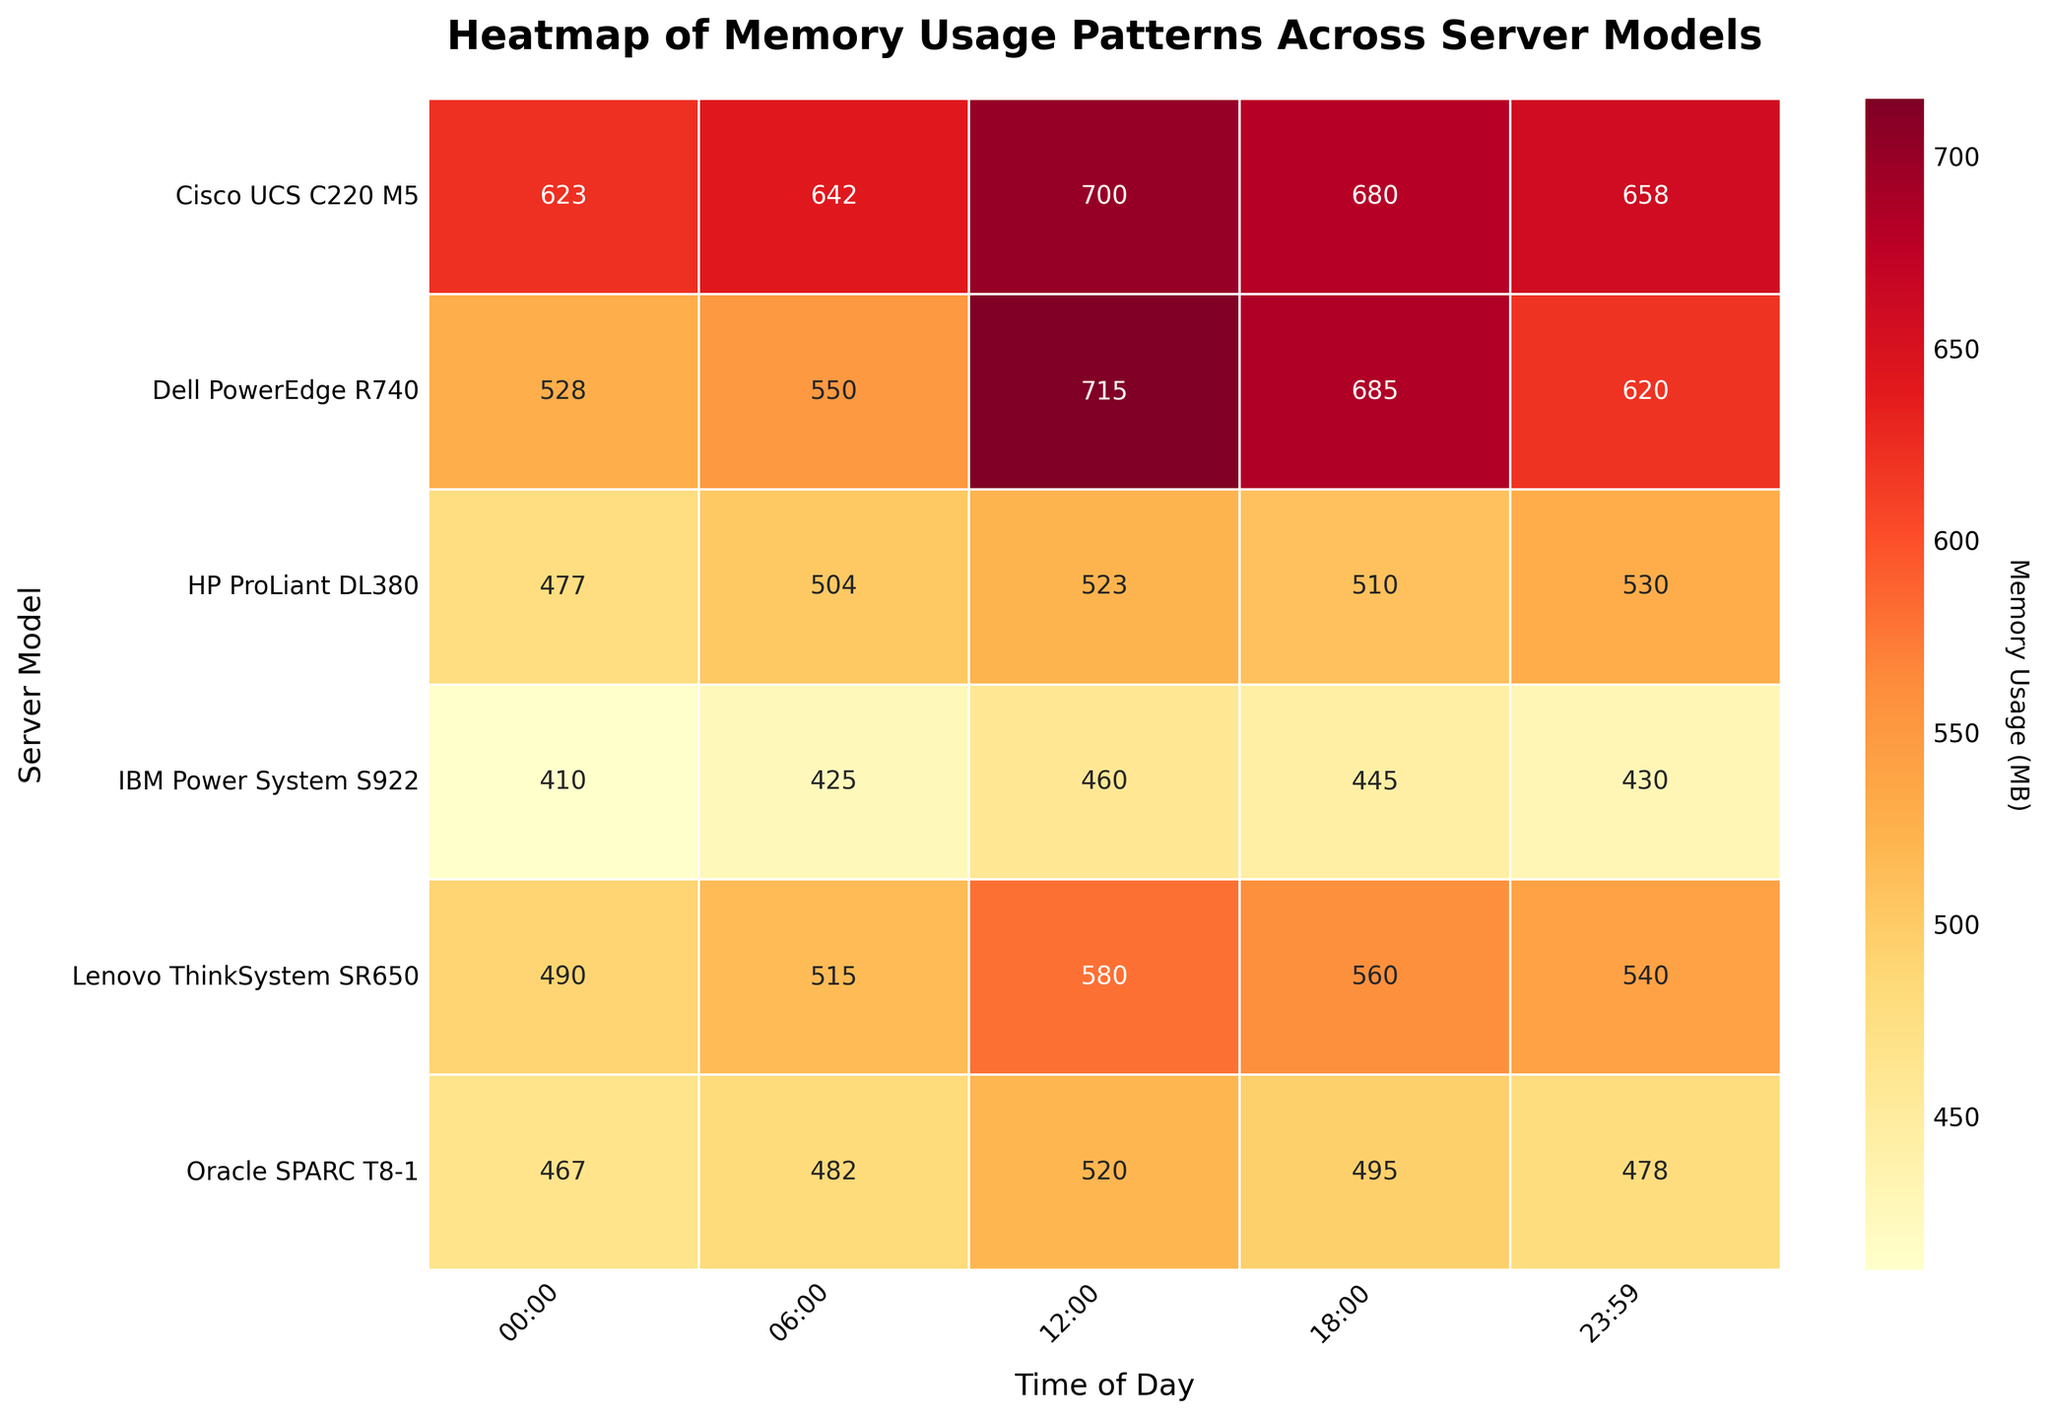What's the title of the heatmap? The title is usually found at the top of the figure, serving as a description of what the heatmap represents.
Answer: Heatmap of Memory Usage Patterns Across Server Models Which server model has the highest memory usage at 12:00? Identify the Time of Day column labeled 12:00, then find the maximum value in that column and note the corresponding server model.
Answer: Dell PowerEdge R740 What is the average memory usage for the Dell PowerEdge R740 across all times of day? Sum the memory usage values for Dell PowerEdge R740 across all times of day and divide by the number of observations (5). Values: 528, 550, 715, 685, 620. Calculation: (528 + 550 + 715 + 685 + 620) / 5 = 3198 / 5 = 639.6
Answer: 639.6 MB Which server model and operating system combination has the lowest memory usage overall? Identify the lowest value in the heatmap and note the corresponding server model and operating system. The lowest value is 410 MB for IBM Power System S922 running AIX 7.2 at 00:00.
Answer: IBM Power System S922, AIX 7.2 How does the memory usage of Cisco UCS C220 M5 at 06:00 compare to 12:00? Locate the memory usage values for Cisco UCS C220 M5 at 06:00 and 12:00 and compare them. At 06:00, it is 642 MB, and at 12:00, it is 700 MB. 700 MB - 642 MB = 58 MB.
Answer: 58 MB more at 12:00 What is the memory usage range for Lenovo ThinkSystem SR650? Find the minimum and maximum memory usage values for Lenovo ThinkSystem SR650 and subtract the minimum from the maximum to get the range. Values: 490 to 580. Calculation: 580 - 490 = 90.
Answer: 90 MB Are there any time slots where HP ProLiant DL380 has higher memory usage than Dell PowerEdge R740? Compare the values for HP ProLiant DL380 and Dell PowerEdge R740 at each time slot. There is no value for HP ProLiant DL380 that is higher than Dell PowerEdge R740 at any time slot.
Answer: No Which time of day generally shows the highest memory usage across all servers? For each time of day, sum the memory usage values for all server models. Identify the time slot with the highest sum. Sums: 00:00 = 2995, 06:00 = 3118, 12:00 = 3498, 18:00 = 3375, 23:59 = 3256.
Answer: 12:00 Does Oracle SPARC T8-1 show consistent memory usage throughout the day, or is there significant variability? Examine the memory usage values for Oracle SPARC T8-1 across all times of day. Values: 467, 482, 520, 495, 478. The differences between the values are relatively small, indicating consistent usage.
Answer: Consistent 